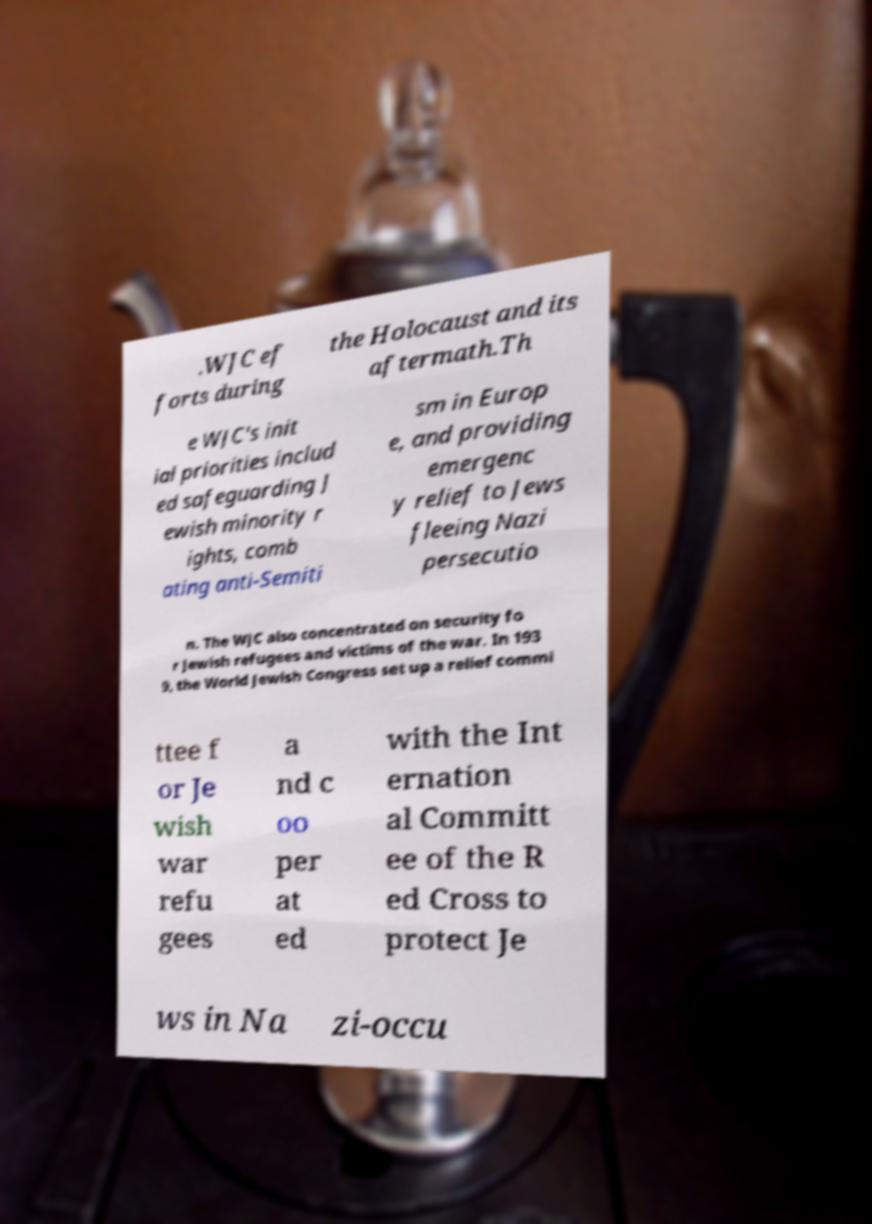Could you assist in decoding the text presented in this image and type it out clearly? .WJC ef forts during the Holocaust and its aftermath.Th e WJC's init ial priorities includ ed safeguarding J ewish minority r ights, comb ating anti-Semiti sm in Europ e, and providing emergenc y relief to Jews fleeing Nazi persecutio n. The WJC also concentrated on security fo r Jewish refugees and victims of the war. In 193 9, the World Jewish Congress set up a relief commi ttee f or Je wish war refu gees a nd c oo per at ed with the Int ernation al Committ ee of the R ed Cross to protect Je ws in Na zi-occu 